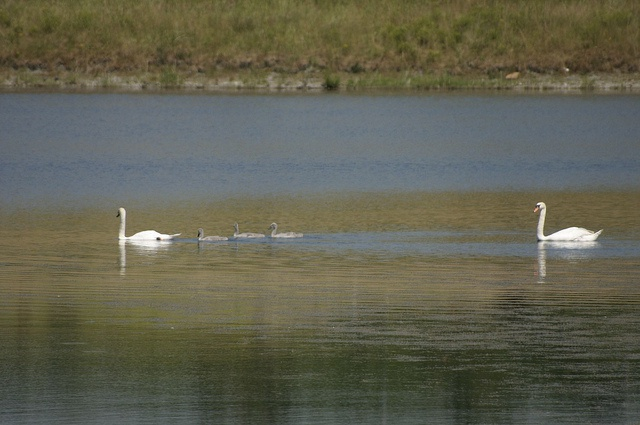Describe the objects in this image and their specific colors. I can see bird in gray, lightgray, and darkgray tones, bird in gray, white, darkgray, and lightgray tones, bird in gray and darkgray tones, bird in gray, darkgray, and lightgray tones, and bird in gray and darkgray tones in this image. 